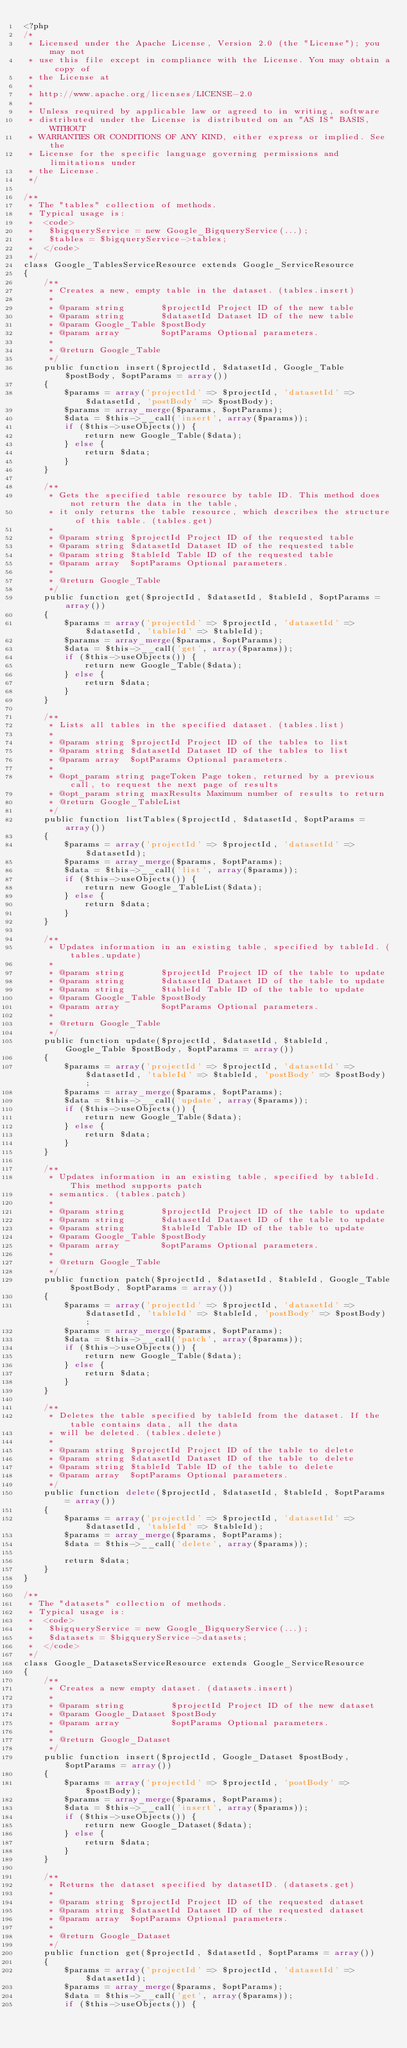Convert code to text. <code><loc_0><loc_0><loc_500><loc_500><_PHP_><?php
/*
 * Licensed under the Apache License, Version 2.0 (the "License"); you may not
 * use this file except in compliance with the License. You may obtain a copy of
 * the License at
 *
 * http://www.apache.org/licenses/LICENSE-2.0
 *
 * Unless required by applicable law or agreed to in writing, software
 * distributed under the License is distributed on an "AS IS" BASIS, WITHOUT
 * WARRANTIES OR CONDITIONS OF ANY KIND, either express or implied. See the
 * License for the specific language governing permissions and limitations under
 * the License.
 */

/**
 * The "tables" collection of methods.
 * Typical usage is:
 *  <code>
 *   $bigqueryService = new Google_BigqueryService(...);
 *   $tables = $bigqueryService->tables;
 *  </code>
 */
class Google_TablesServiceResource extends Google_ServiceResource
{
    /**
     * Creates a new, empty table in the dataset. (tables.insert)
     *
     * @param string       $projectId Project ID of the new table
     * @param string       $datasetId Dataset ID of the new table
     * @param Google_Table $postBody
     * @param array        $optParams Optional parameters.
     *
     * @return Google_Table
     */
    public function insert($projectId, $datasetId, Google_Table $postBody, $optParams = array())
    {
        $params = array('projectId' => $projectId, 'datasetId' => $datasetId, 'postBody' => $postBody);
        $params = array_merge($params, $optParams);
        $data = $this->__call('insert', array($params));
        if ($this->useObjects()) {
            return new Google_Table($data);
        } else {
            return $data;
        }
    }

    /**
     * Gets the specified table resource by table ID. This method does not return the data in the table,
     * it only returns the table resource, which describes the structure of this table. (tables.get)
     *
     * @param string $projectId Project ID of the requested table
     * @param string $datasetId Dataset ID of the requested table
     * @param string $tableId Table ID of the requested table
     * @param array  $optParams Optional parameters.
     *
     * @return Google_Table
     */
    public function get($projectId, $datasetId, $tableId, $optParams = array())
    {
        $params = array('projectId' => $projectId, 'datasetId' => $datasetId, 'tableId' => $tableId);
        $params = array_merge($params, $optParams);
        $data = $this->__call('get', array($params));
        if ($this->useObjects()) {
            return new Google_Table($data);
        } else {
            return $data;
        }
    }

    /**
     * Lists all tables in the specified dataset. (tables.list)
     *
     * @param string $projectId Project ID of the tables to list
     * @param string $datasetId Dataset ID of the tables to list
     * @param array  $optParams Optional parameters.
     *
     * @opt_param string pageToken Page token, returned by a previous call, to request the next page of results
     * @opt_param string maxResults Maximum number of results to return
     * @return Google_TableList
     */
    public function listTables($projectId, $datasetId, $optParams = array())
    {
        $params = array('projectId' => $projectId, 'datasetId' => $datasetId);
        $params = array_merge($params, $optParams);
        $data = $this->__call('list', array($params));
        if ($this->useObjects()) {
            return new Google_TableList($data);
        } else {
            return $data;
        }
    }

    /**
     * Updates information in an existing table, specified by tableId. (tables.update)
     *
     * @param string       $projectId Project ID of the table to update
     * @param string       $datasetId Dataset ID of the table to update
     * @param string       $tableId Table ID of the table to update
     * @param Google_Table $postBody
     * @param array        $optParams Optional parameters.
     *
     * @return Google_Table
     */
    public function update($projectId, $datasetId, $tableId, Google_Table $postBody, $optParams = array())
    {
        $params = array('projectId' => $projectId, 'datasetId' => $datasetId, 'tableId' => $tableId, 'postBody' => $postBody);
        $params = array_merge($params, $optParams);
        $data = $this->__call('update', array($params));
        if ($this->useObjects()) {
            return new Google_Table($data);
        } else {
            return $data;
        }
    }

    /**
     * Updates information in an existing table, specified by tableId. This method supports patch
     * semantics. (tables.patch)
     *
     * @param string       $projectId Project ID of the table to update
     * @param string       $datasetId Dataset ID of the table to update
     * @param string       $tableId Table ID of the table to update
     * @param Google_Table $postBody
     * @param array        $optParams Optional parameters.
     *
     * @return Google_Table
     */
    public function patch($projectId, $datasetId, $tableId, Google_Table $postBody, $optParams = array())
    {
        $params = array('projectId' => $projectId, 'datasetId' => $datasetId, 'tableId' => $tableId, 'postBody' => $postBody);
        $params = array_merge($params, $optParams);
        $data = $this->__call('patch', array($params));
        if ($this->useObjects()) {
            return new Google_Table($data);
        } else {
            return $data;
        }
    }

    /**
     * Deletes the table specified by tableId from the dataset. If the table contains data, all the data
     * will be deleted. (tables.delete)
     *
     * @param string $projectId Project ID of the table to delete
     * @param string $datasetId Dataset ID of the table to delete
     * @param string $tableId Table ID of the table to delete
     * @param array  $optParams Optional parameters.
     */
    public function delete($projectId, $datasetId, $tableId, $optParams = array())
    {
        $params = array('projectId' => $projectId, 'datasetId' => $datasetId, 'tableId' => $tableId);
        $params = array_merge($params, $optParams);
        $data = $this->__call('delete', array($params));

        return $data;
    }
}

/**
 * The "datasets" collection of methods.
 * Typical usage is:
 *  <code>
 *   $bigqueryService = new Google_BigqueryService(...);
 *   $datasets = $bigqueryService->datasets;
 *  </code>
 */
class Google_DatasetsServiceResource extends Google_ServiceResource
{
    /**
     * Creates a new empty dataset. (datasets.insert)
     *
     * @param string         $projectId Project ID of the new dataset
     * @param Google_Dataset $postBody
     * @param array          $optParams Optional parameters.
     *
     * @return Google_Dataset
     */
    public function insert($projectId, Google_Dataset $postBody, $optParams = array())
    {
        $params = array('projectId' => $projectId, 'postBody' => $postBody);
        $params = array_merge($params, $optParams);
        $data = $this->__call('insert', array($params));
        if ($this->useObjects()) {
            return new Google_Dataset($data);
        } else {
            return $data;
        }
    }

    /**
     * Returns the dataset specified by datasetID. (datasets.get)
     *
     * @param string $projectId Project ID of the requested dataset
     * @param string $datasetId Dataset ID of the requested dataset
     * @param array  $optParams Optional parameters.
     *
     * @return Google_Dataset
     */
    public function get($projectId, $datasetId, $optParams = array())
    {
        $params = array('projectId' => $projectId, 'datasetId' => $datasetId);
        $params = array_merge($params, $optParams);
        $data = $this->__call('get', array($params));
        if ($this->useObjects()) {</code> 